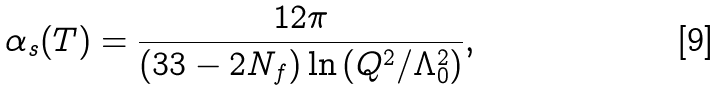<formula> <loc_0><loc_0><loc_500><loc_500>\alpha _ { s } ( T ) = \frac { 1 2 \pi } { ( 3 3 - 2 N _ { f } ) \ln \left ( Q ^ { 2 } / \Lambda _ { 0 } ^ { 2 } \right ) } ,</formula> 